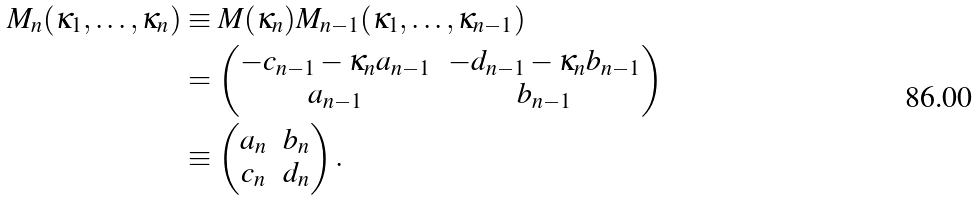Convert formula to latex. <formula><loc_0><loc_0><loc_500><loc_500>M _ { n } ( \kappa _ { 1 } , \dots , \kappa _ { n } ) & \equiv M ( \kappa _ { n } ) M _ { n - 1 } ( \kappa _ { 1 } , \dots , \kappa _ { n - 1 } ) \\ & = \begin{pmatrix} - c _ { n - 1 } - \kappa _ { n } a _ { n - 1 } & - d _ { n - 1 } - \kappa _ { n } b _ { n - 1 } \\ a _ { n - 1 } & b _ { n - 1 } \end{pmatrix} \\ & \equiv \begin{pmatrix} a _ { n } & b _ { n } \\ c _ { n } & d _ { n } \end{pmatrix} .</formula> 